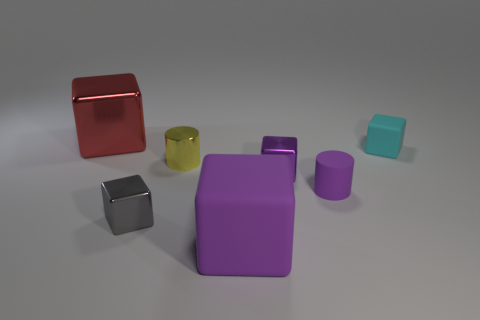Subtract all gray spheres. How many purple blocks are left? 2 Subtract all large red metallic blocks. How many blocks are left? 4 Add 3 small purple cylinders. How many objects exist? 10 Subtract all purple cubes. How many cubes are left? 3 Subtract all gray cubes. Subtract all gray cylinders. How many cubes are left? 4 Subtract all blocks. How many objects are left? 2 Add 1 small rubber balls. How many small rubber balls exist? 1 Subtract 0 yellow blocks. How many objects are left? 7 Subtract all large green metal objects. Subtract all purple cylinders. How many objects are left? 6 Add 3 tiny purple rubber cylinders. How many tiny purple rubber cylinders are left? 4 